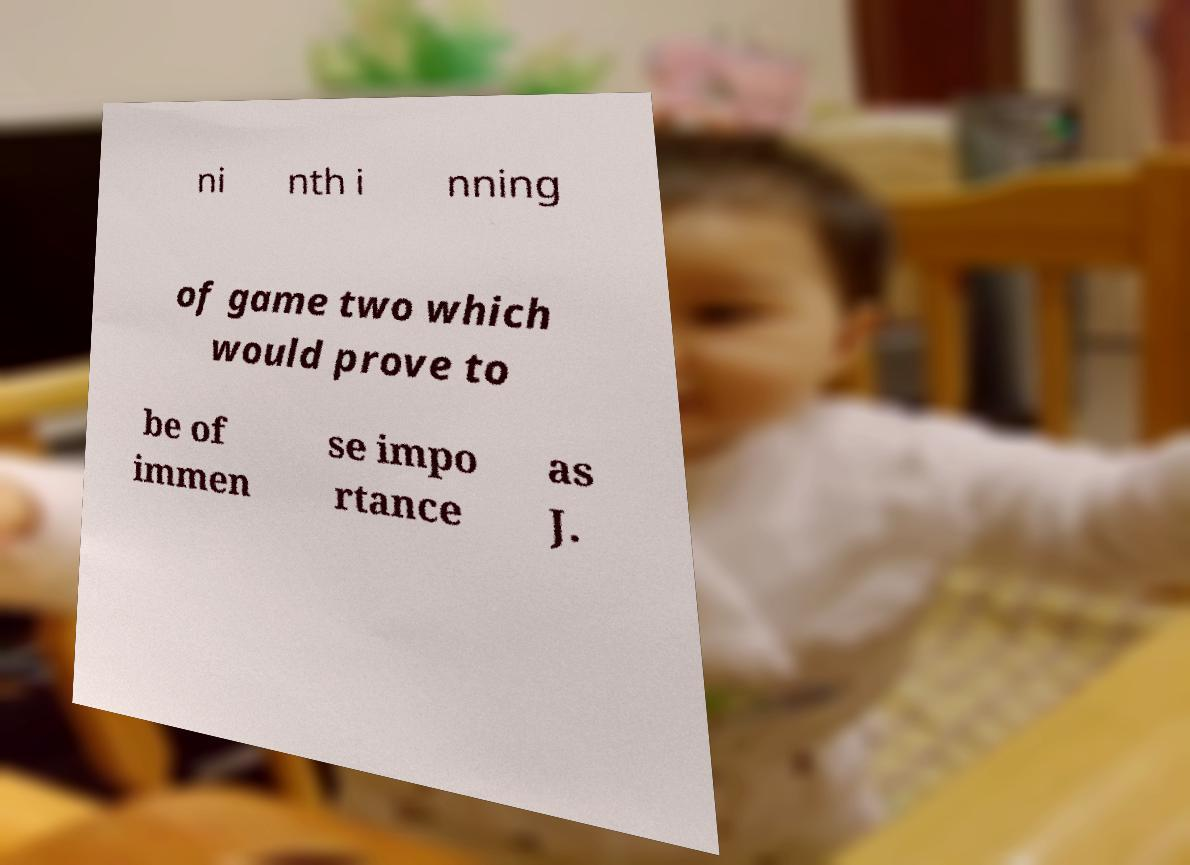Can you read and provide the text displayed in the image?This photo seems to have some interesting text. Can you extract and type it out for me? ni nth i nning of game two which would prove to be of immen se impo rtance as J. 